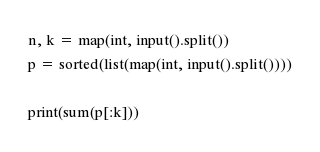<code> <loc_0><loc_0><loc_500><loc_500><_Python_>n, k = map(int, input().split())
p = sorted(list(map(int, input().split())))

print(sum(p[:k]))</code> 